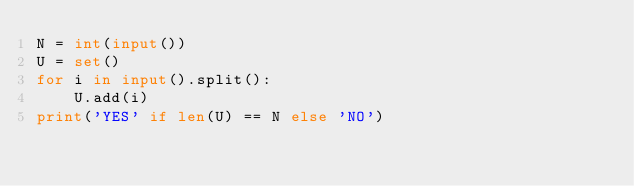Convert code to text. <code><loc_0><loc_0><loc_500><loc_500><_Python_>N = int(input())
U = set()
for i in input().split():
    U.add(i)
print('YES' if len(U) == N else 'NO')</code> 